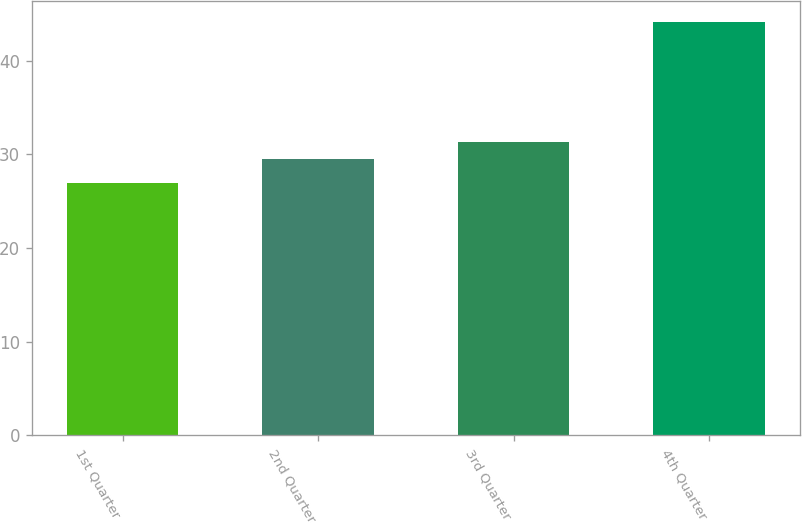Convert chart to OTSL. <chart><loc_0><loc_0><loc_500><loc_500><bar_chart><fcel>1st Quarter<fcel>2nd Quarter<fcel>3rd Quarter<fcel>4th Quarter<nl><fcel>26.91<fcel>29.46<fcel>31.35<fcel>44.15<nl></chart> 